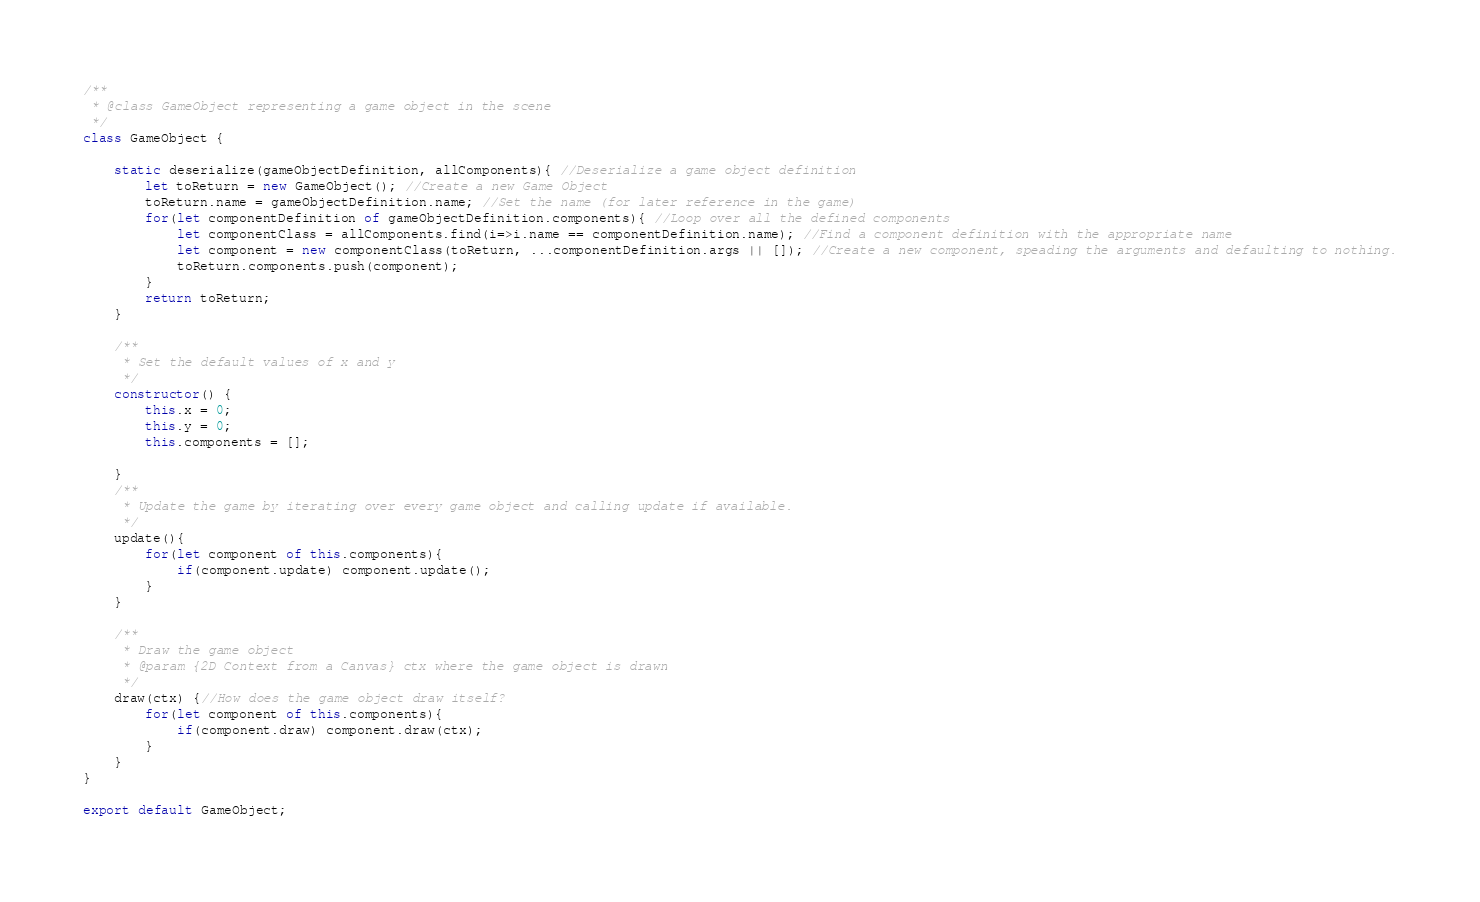<code> <loc_0><loc_0><loc_500><loc_500><_JavaScript_>/**
 * @class GameObject representing a game object in the scene
 */
class GameObject {

    static deserialize(gameObjectDefinition, allComponents){ //Deserialize a game object definition
        let toReturn = new GameObject(); //Create a new Game Object
        toReturn.name = gameObjectDefinition.name; //Set the name (for later reference in the game)
        for(let componentDefinition of gameObjectDefinition.components){ //Loop over all the defined components
            let componentClass = allComponents.find(i=>i.name == componentDefinition.name); //Find a component definition with the appropriate name
            let component = new componentClass(toReturn, ...componentDefinition.args || []); //Create a new component, speading the arguments and defaulting to nothing.
            toReturn.components.push(component);
        }
        return toReturn;
    }

    /**
     * Set the default values of x and y
     */
    constructor() {
        this.x = 0; 
        this.y = 0;
        this.components = [];
        
    }
    /**
     * Update the game by iterating over every game object and calling update if available.
     */
    update(){
        for(let component of this.components){
            if(component.update) component.update();
        }
    }
    
    /**
     * Draw the game object
     * @param {2D Context from a Canvas} ctx where the game object is drawn
     */
    draw(ctx) {//How does the game object draw itself?
        for(let component of this.components){
            if(component.draw) component.draw(ctx);
        }
    }
}

export default GameObject;</code> 